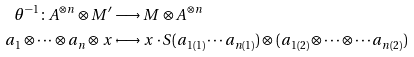Convert formula to latex. <formula><loc_0><loc_0><loc_500><loc_500>\theta ^ { - 1 } \colon A ^ { \otimes n } \otimes M ^ { \prime } & \longrightarrow M \otimes A ^ { \otimes n } \\ a _ { 1 } \otimes \cdots \otimes a _ { n } \otimes x & \longmapsto x \cdot S ( a _ { 1 ( 1 ) } \cdots a _ { n ( 1 ) } ) \otimes ( a _ { 1 ( 2 ) } \otimes \cdots \otimes \cdots a _ { n ( 2 ) } )</formula> 